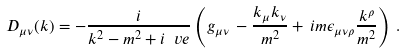<formula> <loc_0><loc_0><loc_500><loc_500>D _ { \mu \nu } ( k ) = - \frac { i } { k ^ { 2 } - m ^ { 2 } + i \ v e } \left ( g _ { \mu \nu } \, - \frac { k _ { \mu } k _ { \nu } } { m ^ { 2 } } + \, i m \epsilon _ { \mu \nu \rho } \frac { k ^ { \rho } } { m ^ { 2 } } \right ) \, .</formula> 